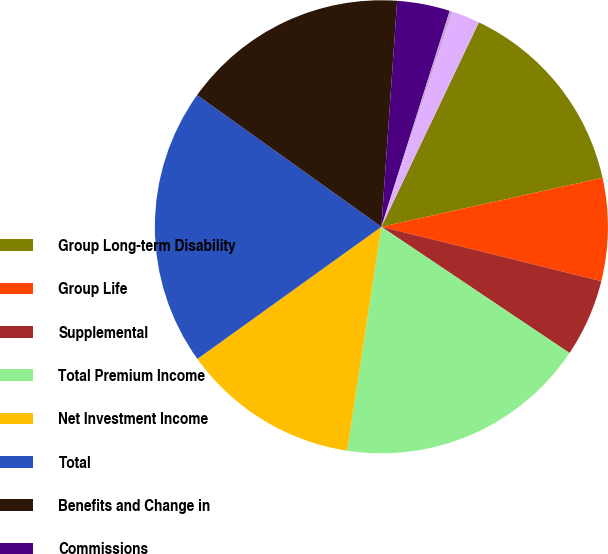<chart> <loc_0><loc_0><loc_500><loc_500><pie_chart><fcel>Group Long-term Disability<fcel>Group Life<fcel>Supplemental<fcel>Total Premium Income<fcel>Net Investment Income<fcel>Total<fcel>Benefits and Change in<fcel>Commissions<fcel>Deferral of Acquisition Costs<fcel>Amortization of Deferred<nl><fcel>14.45%<fcel>7.33%<fcel>5.55%<fcel>18.01%<fcel>12.67%<fcel>19.79%<fcel>16.23%<fcel>3.77%<fcel>0.21%<fcel>1.99%<nl></chart> 